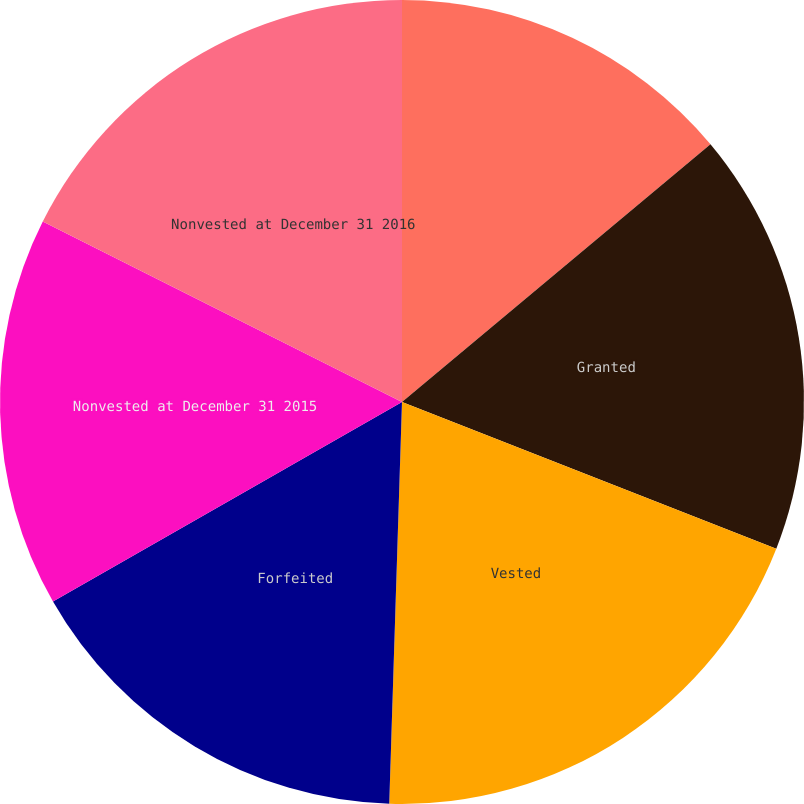<chart> <loc_0><loc_0><loc_500><loc_500><pie_chart><fcel>Nonvested at December 31 2014<fcel>Granted<fcel>Vested<fcel>Forfeited<fcel>Nonvested at December 31 2015<fcel>Nonvested at December 31 2016<nl><fcel>13.92%<fcel>17.02%<fcel>19.56%<fcel>16.23%<fcel>15.67%<fcel>17.59%<nl></chart> 